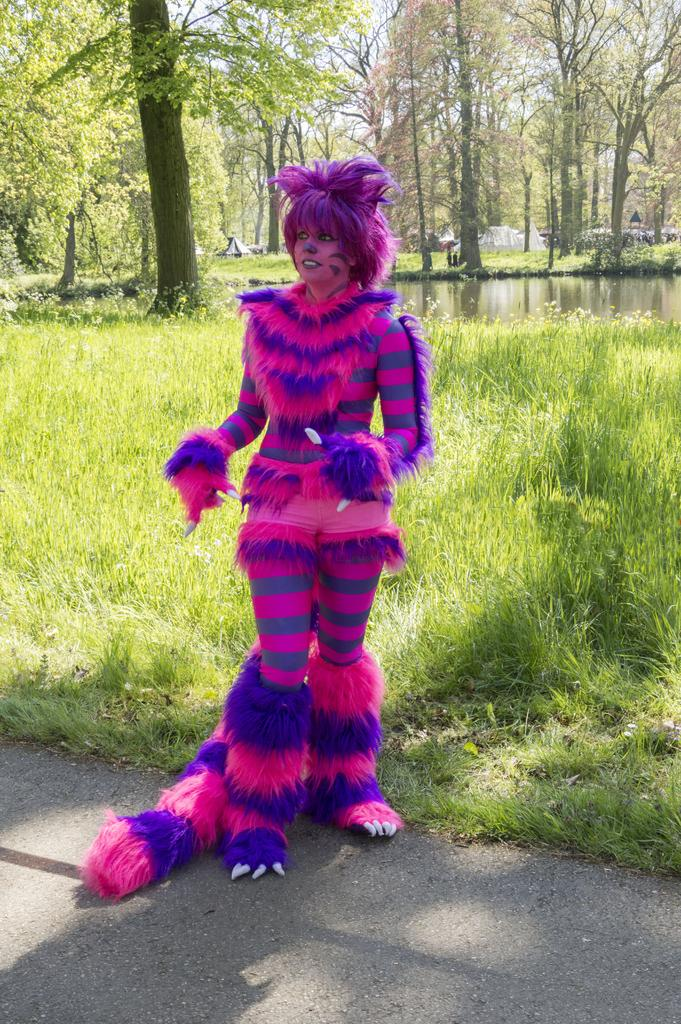What is the woman in the image wearing? The woman is wearing a costume. What is the weather like in the image? The image is taken during a sunny day. What can be seen in the background of the image? There is grass, water, trees, a hut, and the sky visible in the background of the image. What type of dinosaurs can be seen in the image? There are no dinosaurs present in the image. How does the fog affect the visibility in the image? There is no fog present in the image, so it does not affect the visibility. 